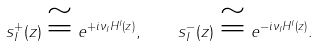Convert formula to latex. <formula><loc_0><loc_0><loc_500><loc_500>s _ { I } ^ { + } ( z ) \cong e ^ { + i \nu _ { I } H ^ { I } ( z ) } , \quad s _ { I } ^ { - } ( z ) \cong e ^ { - i \nu _ { I } H ^ { I } ( z ) } .</formula> 